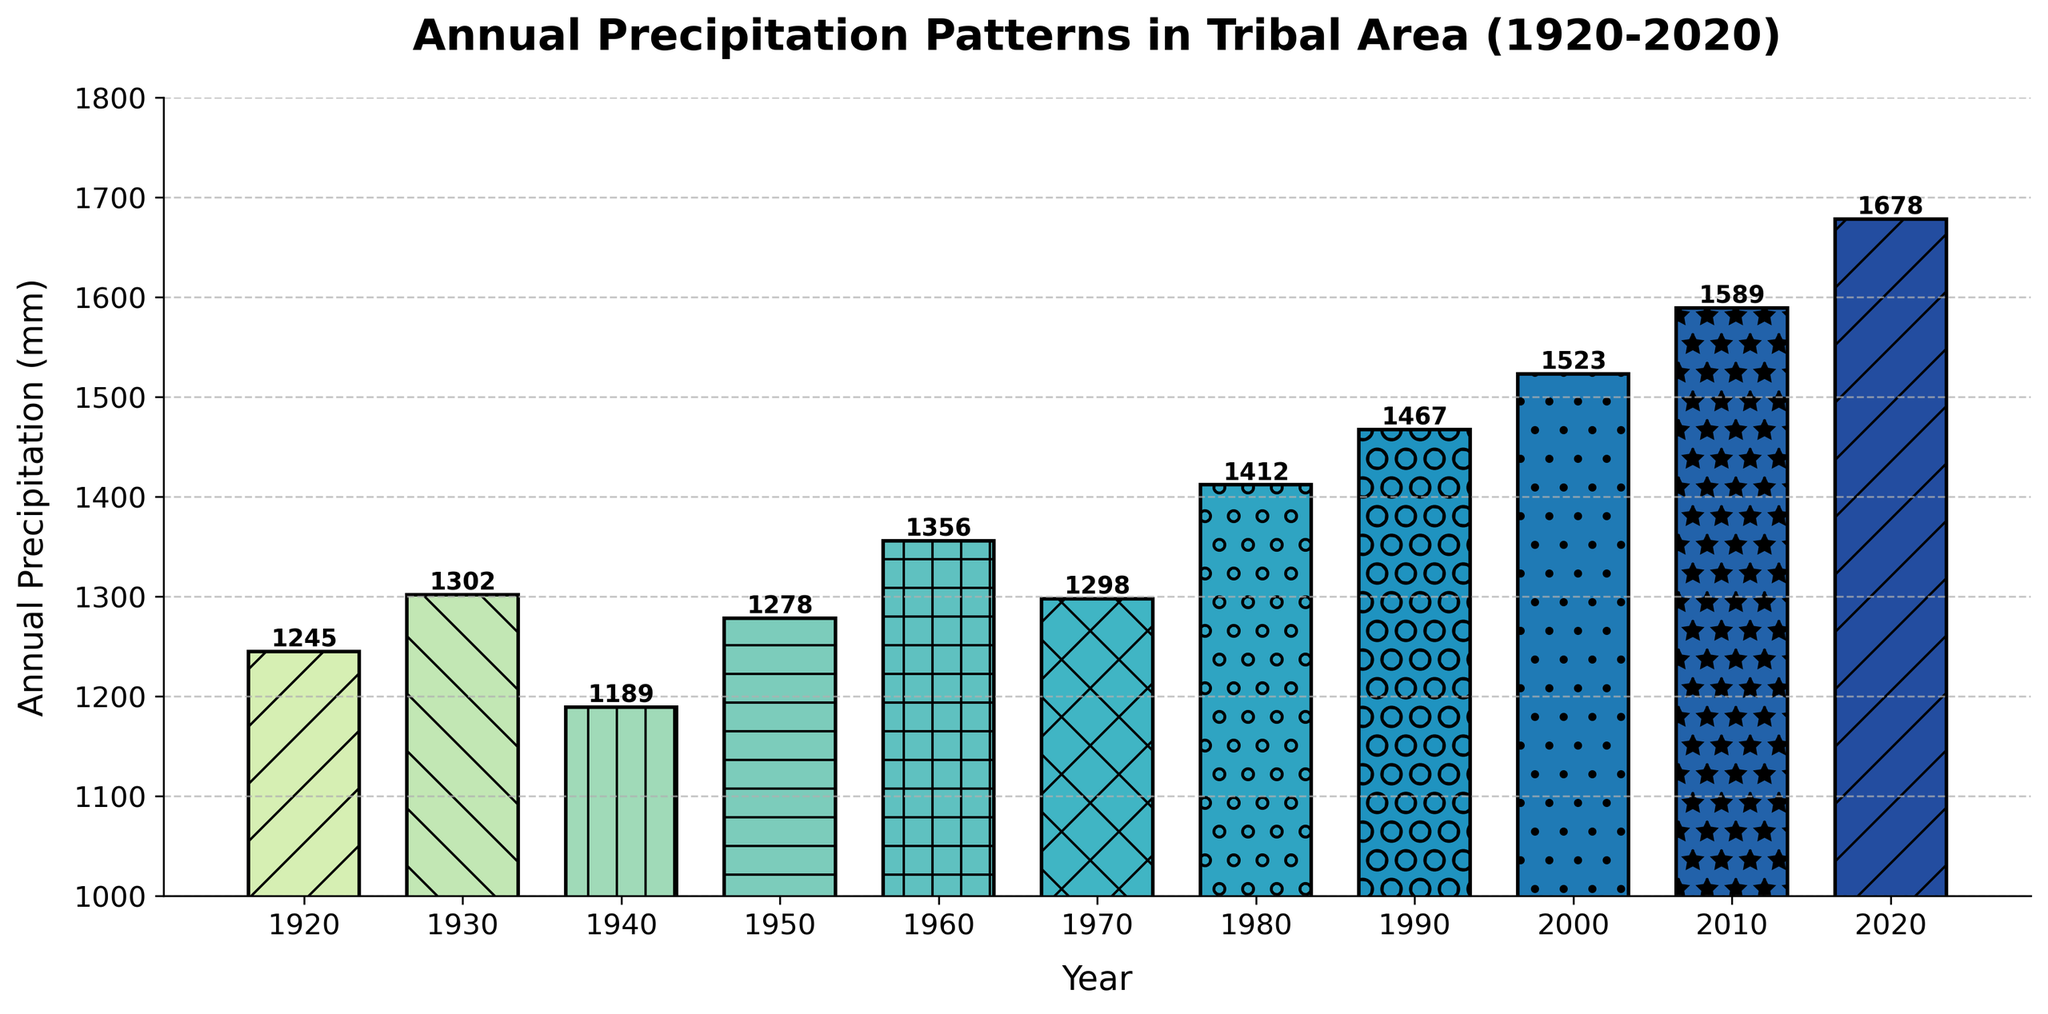What's the highest annual precipitation recorded in the figure? The highest annual precipitation is visually indicated by the tallest bar, which is labeled 1678 mm in the year 2020.
Answer: 1678 mm During which decade did the highest increase in annual precipitation occur? To determine the highest increase, compare the annual precipitation at the end of each decade to the beginning: 
1920-1930: 1302 - 1245 = 57 mm 
1930-1940: 1189 - 1302 = -113 mm 
1940-1950: 1278 - 1189 = 89 mm 
1950-1960: 1356 - 1278 = 78 mm 
1960-1970: 1298 - 1356 = -58 mm 
1970-1980: 1412 - 1298 = 114 mm 
1980-1990: 1467 - 1412 = 55 mm 
1990-2000: 1523 - 1467 = 56 mm 
2000-2010: 1589 - 1523 = 66 mm 
2010-2020: 1678 - 1589 = 89 mm
The highest increase is from 1920-1930.
Answer: 1920-1930 What is the average annual precipitation from 1920 to 2020? Sum up the annual precipitation values and divide by the number of data points: 
(1245 + 1302 + 1189 + 1278 + 1356 + 1298 + 1412 + 1467 + 1523 + 1589 + 1678) = 16337 mm 
Average: 16337 / 11 ≈ 1485.18 mm
Answer: 1485.18 mm Which year had precisely 1412 mm of precipitation? Look for the bar annotated with 1412 mm, which corresponds to the year 1980.
Answer: 1980 How has the annual precipitation trend changed over the century? By observing the heights of the bars, an increasing trend over the century is evident from values around 1200-1300 mm in the early years to around 1600-1700 mm in recent years.
Answer: Increasing What visual pattern is applied to the bars representing the years 1960 and 2000? The bars for 1960 and 2000 have distinctive hatch patterns. 1960 is indicated with a '+' pattern and 2000 with an 'o' pattern.
Answer: '+' and 'o' 